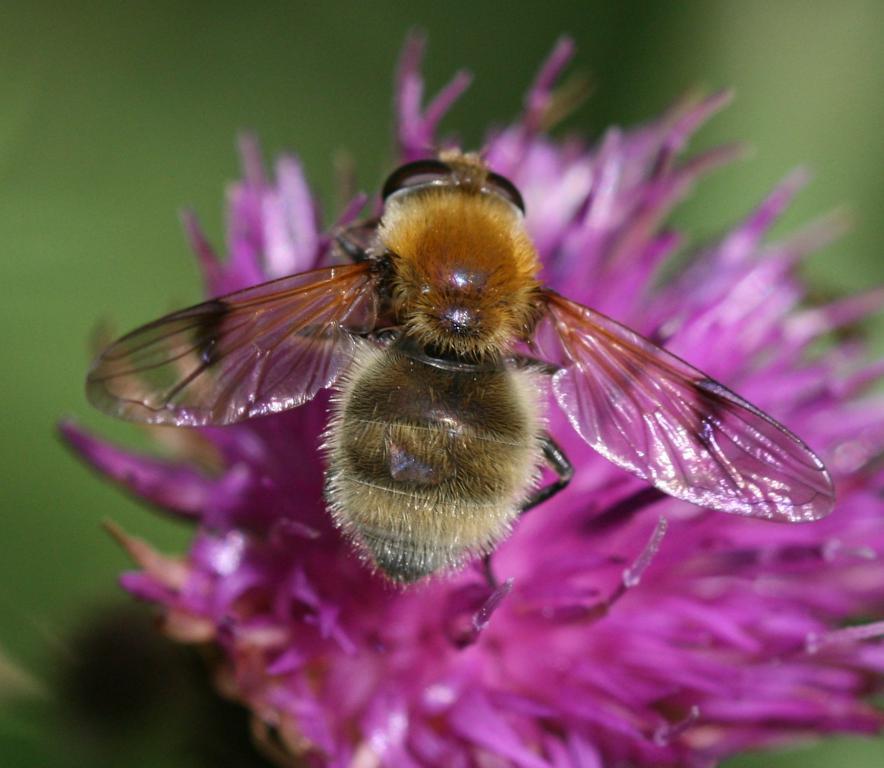Could you give a brief overview of what you see in this image? In this picture we can see a flower here, we can see a honey bee on the flower, there is a blurry background. 